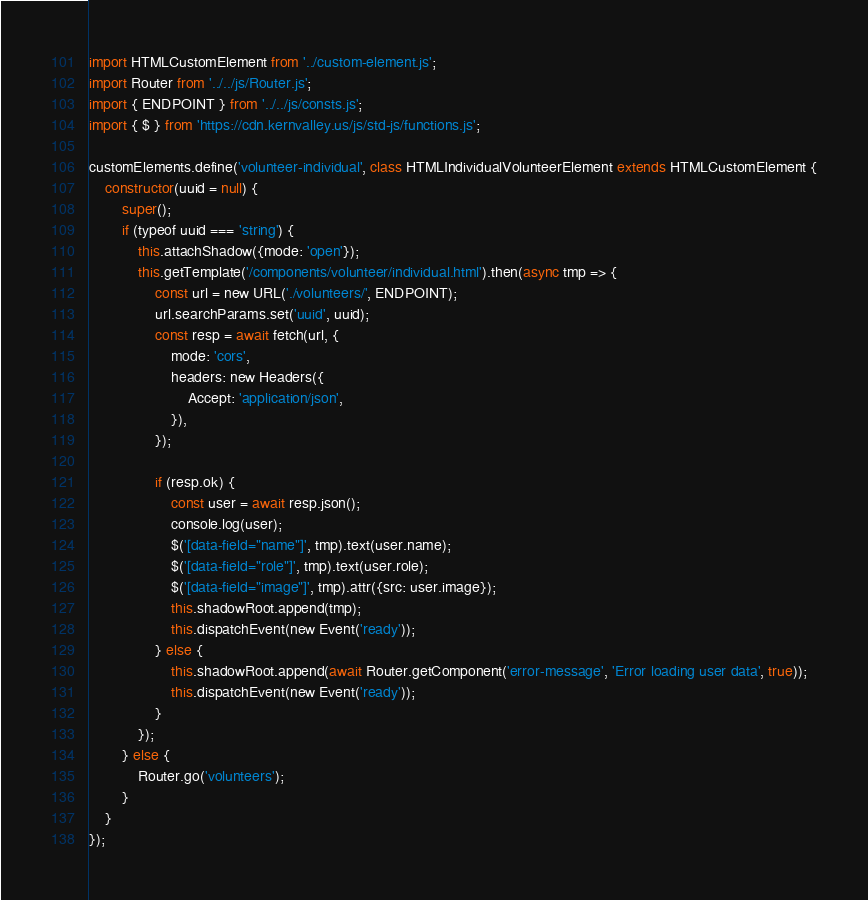Convert code to text. <code><loc_0><loc_0><loc_500><loc_500><_JavaScript_>import HTMLCustomElement from '../custom-element.js';
import Router from '../../js/Router.js';
import { ENDPOINT } from '../../js/consts.js';
import { $ } from 'https://cdn.kernvalley.us/js/std-js/functions.js';

customElements.define('volunteer-individual', class HTMLIndividualVolunteerElement extends HTMLCustomElement {
	constructor(uuid = null) {
		super();
		if (typeof uuid === 'string') {
			this.attachShadow({mode: 'open'});
			this.getTemplate('/components/volunteer/individual.html').then(async tmp => {
				const url = new URL('./volunteers/', ENDPOINT);
				url.searchParams.set('uuid', uuid);
				const resp = await fetch(url, {
					mode: 'cors',
					headers: new Headers({
						Accept: 'application/json',
					}),
				});

				if (resp.ok) {
					const user = await resp.json();
					console.log(user);
					$('[data-field="name"]', tmp).text(user.name);
					$('[data-field="role"]', tmp).text(user.role);
					$('[data-field="image"]', tmp).attr({src: user.image});
					this.shadowRoot.append(tmp);
					this.dispatchEvent(new Event('ready'));
				} else {
					this.shadowRoot.append(await Router.getComponent('error-message', 'Error loading user data', true));
					this.dispatchEvent(new Event('ready'));
				}
			});
		} else {
			Router.go('volunteers');
		}
	}
});
</code> 